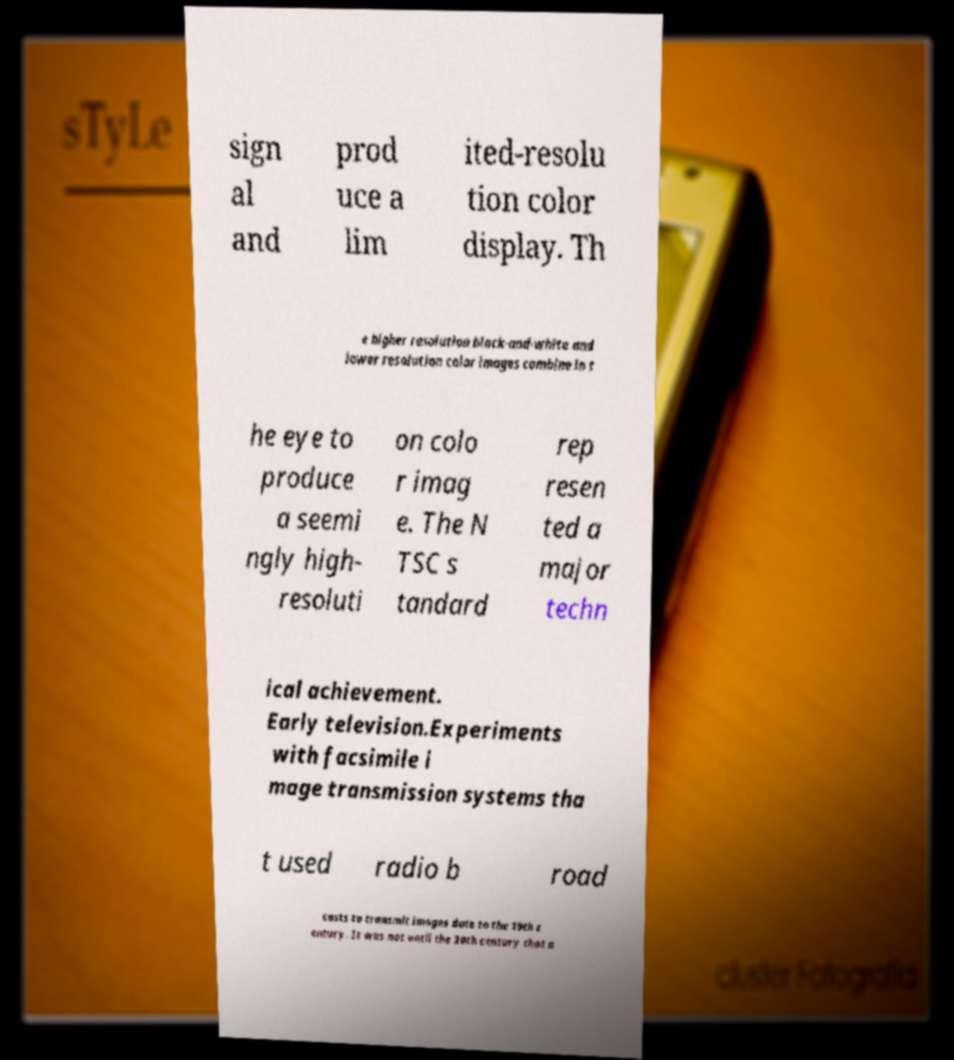Can you read and provide the text displayed in the image?This photo seems to have some interesting text. Can you extract and type it out for me? sign al and prod uce a lim ited-resolu tion color display. Th e higher resolution black-and-white and lower resolution color images combine in t he eye to produce a seemi ngly high- resoluti on colo r imag e. The N TSC s tandard rep resen ted a major techn ical achievement. Early television.Experiments with facsimile i mage transmission systems tha t used radio b road casts to transmit images date to the 19th c entury. It was not until the 20th century that a 